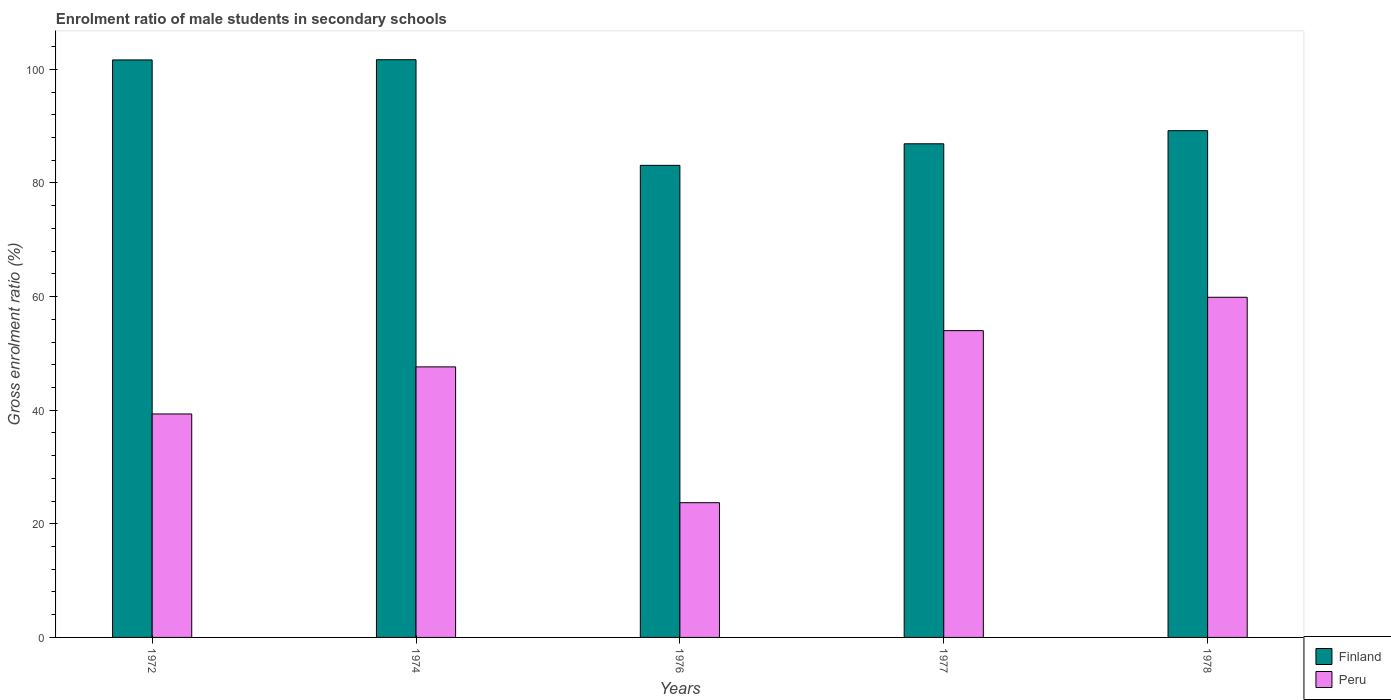How many different coloured bars are there?
Your answer should be compact. 2. Are the number of bars per tick equal to the number of legend labels?
Your answer should be compact. Yes. In how many cases, is the number of bars for a given year not equal to the number of legend labels?
Give a very brief answer. 0. What is the enrolment ratio of male students in secondary schools in Peru in 1977?
Your response must be concise. 54. Across all years, what is the maximum enrolment ratio of male students in secondary schools in Peru?
Keep it short and to the point. 59.88. Across all years, what is the minimum enrolment ratio of male students in secondary schools in Finland?
Provide a succinct answer. 83.1. In which year was the enrolment ratio of male students in secondary schools in Finland maximum?
Keep it short and to the point. 1974. In which year was the enrolment ratio of male students in secondary schools in Peru minimum?
Provide a succinct answer. 1976. What is the total enrolment ratio of male students in secondary schools in Finland in the graph?
Ensure brevity in your answer.  462.54. What is the difference between the enrolment ratio of male students in secondary schools in Finland in 1972 and that in 1976?
Ensure brevity in your answer.  18.56. What is the difference between the enrolment ratio of male students in secondary schools in Peru in 1977 and the enrolment ratio of male students in secondary schools in Finland in 1974?
Your answer should be compact. -47.69. What is the average enrolment ratio of male students in secondary schools in Finland per year?
Offer a terse response. 92.51. In the year 1974, what is the difference between the enrolment ratio of male students in secondary schools in Peru and enrolment ratio of male students in secondary schools in Finland?
Your answer should be very brief. -54.07. In how many years, is the enrolment ratio of male students in secondary schools in Peru greater than 44 %?
Make the answer very short. 3. What is the ratio of the enrolment ratio of male students in secondary schools in Peru in 1977 to that in 1978?
Give a very brief answer. 0.9. Is the enrolment ratio of male students in secondary schools in Finland in 1972 less than that in 1977?
Provide a succinct answer. No. Is the difference between the enrolment ratio of male students in secondary schools in Peru in 1976 and 1977 greater than the difference between the enrolment ratio of male students in secondary schools in Finland in 1976 and 1977?
Offer a terse response. No. What is the difference between the highest and the second highest enrolment ratio of male students in secondary schools in Finland?
Offer a very short reply. 0.04. What is the difference between the highest and the lowest enrolment ratio of male students in secondary schools in Peru?
Offer a terse response. 36.16. In how many years, is the enrolment ratio of male students in secondary schools in Finland greater than the average enrolment ratio of male students in secondary schools in Finland taken over all years?
Your answer should be compact. 2. What does the 2nd bar from the right in 1972 represents?
Give a very brief answer. Finland. What is the difference between two consecutive major ticks on the Y-axis?
Your response must be concise. 20. Does the graph contain grids?
Your answer should be very brief. No. What is the title of the graph?
Your answer should be compact. Enrolment ratio of male students in secondary schools. What is the label or title of the Y-axis?
Provide a succinct answer. Gross enrolment ratio (%). What is the Gross enrolment ratio (%) in Finland in 1972?
Ensure brevity in your answer.  101.66. What is the Gross enrolment ratio (%) of Peru in 1972?
Your answer should be compact. 39.34. What is the Gross enrolment ratio (%) in Finland in 1974?
Your response must be concise. 101.69. What is the Gross enrolment ratio (%) in Peru in 1974?
Make the answer very short. 47.62. What is the Gross enrolment ratio (%) of Finland in 1976?
Offer a very short reply. 83.1. What is the Gross enrolment ratio (%) of Peru in 1976?
Offer a very short reply. 23.71. What is the Gross enrolment ratio (%) of Finland in 1977?
Keep it short and to the point. 86.89. What is the Gross enrolment ratio (%) of Peru in 1977?
Give a very brief answer. 54. What is the Gross enrolment ratio (%) of Finland in 1978?
Your answer should be very brief. 89.2. What is the Gross enrolment ratio (%) of Peru in 1978?
Offer a terse response. 59.88. Across all years, what is the maximum Gross enrolment ratio (%) in Finland?
Ensure brevity in your answer.  101.69. Across all years, what is the maximum Gross enrolment ratio (%) in Peru?
Your response must be concise. 59.88. Across all years, what is the minimum Gross enrolment ratio (%) in Finland?
Your answer should be very brief. 83.1. Across all years, what is the minimum Gross enrolment ratio (%) in Peru?
Offer a very short reply. 23.71. What is the total Gross enrolment ratio (%) of Finland in the graph?
Provide a succinct answer. 462.54. What is the total Gross enrolment ratio (%) of Peru in the graph?
Ensure brevity in your answer.  224.55. What is the difference between the Gross enrolment ratio (%) in Finland in 1972 and that in 1974?
Your response must be concise. -0.04. What is the difference between the Gross enrolment ratio (%) in Peru in 1972 and that in 1974?
Make the answer very short. -8.28. What is the difference between the Gross enrolment ratio (%) of Finland in 1972 and that in 1976?
Offer a terse response. 18.56. What is the difference between the Gross enrolment ratio (%) in Peru in 1972 and that in 1976?
Your response must be concise. 15.62. What is the difference between the Gross enrolment ratio (%) in Finland in 1972 and that in 1977?
Your response must be concise. 14.76. What is the difference between the Gross enrolment ratio (%) of Peru in 1972 and that in 1977?
Your answer should be compact. -14.67. What is the difference between the Gross enrolment ratio (%) in Finland in 1972 and that in 1978?
Offer a very short reply. 12.45. What is the difference between the Gross enrolment ratio (%) in Peru in 1972 and that in 1978?
Provide a short and direct response. -20.54. What is the difference between the Gross enrolment ratio (%) in Finland in 1974 and that in 1976?
Offer a very short reply. 18.59. What is the difference between the Gross enrolment ratio (%) in Peru in 1974 and that in 1976?
Give a very brief answer. 23.91. What is the difference between the Gross enrolment ratio (%) in Finland in 1974 and that in 1977?
Your response must be concise. 14.8. What is the difference between the Gross enrolment ratio (%) in Peru in 1974 and that in 1977?
Keep it short and to the point. -6.38. What is the difference between the Gross enrolment ratio (%) of Finland in 1974 and that in 1978?
Offer a very short reply. 12.49. What is the difference between the Gross enrolment ratio (%) of Peru in 1974 and that in 1978?
Your answer should be compact. -12.26. What is the difference between the Gross enrolment ratio (%) of Finland in 1976 and that in 1977?
Offer a very short reply. -3.79. What is the difference between the Gross enrolment ratio (%) in Peru in 1976 and that in 1977?
Provide a short and direct response. -30.29. What is the difference between the Gross enrolment ratio (%) in Finland in 1976 and that in 1978?
Your answer should be compact. -6.1. What is the difference between the Gross enrolment ratio (%) in Peru in 1976 and that in 1978?
Make the answer very short. -36.16. What is the difference between the Gross enrolment ratio (%) of Finland in 1977 and that in 1978?
Your answer should be very brief. -2.31. What is the difference between the Gross enrolment ratio (%) of Peru in 1977 and that in 1978?
Your answer should be compact. -5.87. What is the difference between the Gross enrolment ratio (%) of Finland in 1972 and the Gross enrolment ratio (%) of Peru in 1974?
Your response must be concise. 54.03. What is the difference between the Gross enrolment ratio (%) of Finland in 1972 and the Gross enrolment ratio (%) of Peru in 1976?
Ensure brevity in your answer.  77.94. What is the difference between the Gross enrolment ratio (%) of Finland in 1972 and the Gross enrolment ratio (%) of Peru in 1977?
Keep it short and to the point. 47.65. What is the difference between the Gross enrolment ratio (%) of Finland in 1972 and the Gross enrolment ratio (%) of Peru in 1978?
Offer a terse response. 41.78. What is the difference between the Gross enrolment ratio (%) of Finland in 1974 and the Gross enrolment ratio (%) of Peru in 1976?
Your response must be concise. 77.98. What is the difference between the Gross enrolment ratio (%) of Finland in 1974 and the Gross enrolment ratio (%) of Peru in 1977?
Your response must be concise. 47.69. What is the difference between the Gross enrolment ratio (%) in Finland in 1974 and the Gross enrolment ratio (%) in Peru in 1978?
Provide a succinct answer. 41.82. What is the difference between the Gross enrolment ratio (%) of Finland in 1976 and the Gross enrolment ratio (%) of Peru in 1977?
Your response must be concise. 29.1. What is the difference between the Gross enrolment ratio (%) of Finland in 1976 and the Gross enrolment ratio (%) of Peru in 1978?
Ensure brevity in your answer.  23.22. What is the difference between the Gross enrolment ratio (%) in Finland in 1977 and the Gross enrolment ratio (%) in Peru in 1978?
Give a very brief answer. 27.02. What is the average Gross enrolment ratio (%) of Finland per year?
Provide a succinct answer. 92.51. What is the average Gross enrolment ratio (%) of Peru per year?
Give a very brief answer. 44.91. In the year 1972, what is the difference between the Gross enrolment ratio (%) of Finland and Gross enrolment ratio (%) of Peru?
Your response must be concise. 62.32. In the year 1974, what is the difference between the Gross enrolment ratio (%) in Finland and Gross enrolment ratio (%) in Peru?
Make the answer very short. 54.07. In the year 1976, what is the difference between the Gross enrolment ratio (%) of Finland and Gross enrolment ratio (%) of Peru?
Your answer should be very brief. 59.38. In the year 1977, what is the difference between the Gross enrolment ratio (%) in Finland and Gross enrolment ratio (%) in Peru?
Provide a succinct answer. 32.89. In the year 1978, what is the difference between the Gross enrolment ratio (%) of Finland and Gross enrolment ratio (%) of Peru?
Provide a succinct answer. 29.32. What is the ratio of the Gross enrolment ratio (%) in Finland in 1972 to that in 1974?
Your answer should be compact. 1. What is the ratio of the Gross enrolment ratio (%) in Peru in 1972 to that in 1974?
Make the answer very short. 0.83. What is the ratio of the Gross enrolment ratio (%) of Finland in 1972 to that in 1976?
Ensure brevity in your answer.  1.22. What is the ratio of the Gross enrolment ratio (%) in Peru in 1972 to that in 1976?
Ensure brevity in your answer.  1.66. What is the ratio of the Gross enrolment ratio (%) of Finland in 1972 to that in 1977?
Keep it short and to the point. 1.17. What is the ratio of the Gross enrolment ratio (%) in Peru in 1972 to that in 1977?
Offer a very short reply. 0.73. What is the ratio of the Gross enrolment ratio (%) of Finland in 1972 to that in 1978?
Provide a short and direct response. 1.14. What is the ratio of the Gross enrolment ratio (%) of Peru in 1972 to that in 1978?
Give a very brief answer. 0.66. What is the ratio of the Gross enrolment ratio (%) in Finland in 1974 to that in 1976?
Your response must be concise. 1.22. What is the ratio of the Gross enrolment ratio (%) of Peru in 1974 to that in 1976?
Offer a terse response. 2.01. What is the ratio of the Gross enrolment ratio (%) in Finland in 1974 to that in 1977?
Your answer should be very brief. 1.17. What is the ratio of the Gross enrolment ratio (%) in Peru in 1974 to that in 1977?
Keep it short and to the point. 0.88. What is the ratio of the Gross enrolment ratio (%) of Finland in 1974 to that in 1978?
Make the answer very short. 1.14. What is the ratio of the Gross enrolment ratio (%) of Peru in 1974 to that in 1978?
Your answer should be compact. 0.8. What is the ratio of the Gross enrolment ratio (%) of Finland in 1976 to that in 1977?
Offer a very short reply. 0.96. What is the ratio of the Gross enrolment ratio (%) of Peru in 1976 to that in 1977?
Provide a succinct answer. 0.44. What is the ratio of the Gross enrolment ratio (%) in Finland in 1976 to that in 1978?
Your answer should be compact. 0.93. What is the ratio of the Gross enrolment ratio (%) of Peru in 1976 to that in 1978?
Give a very brief answer. 0.4. What is the ratio of the Gross enrolment ratio (%) in Finland in 1977 to that in 1978?
Your answer should be compact. 0.97. What is the ratio of the Gross enrolment ratio (%) of Peru in 1977 to that in 1978?
Provide a short and direct response. 0.9. What is the difference between the highest and the second highest Gross enrolment ratio (%) in Finland?
Offer a very short reply. 0.04. What is the difference between the highest and the second highest Gross enrolment ratio (%) in Peru?
Offer a terse response. 5.87. What is the difference between the highest and the lowest Gross enrolment ratio (%) in Finland?
Offer a terse response. 18.59. What is the difference between the highest and the lowest Gross enrolment ratio (%) of Peru?
Ensure brevity in your answer.  36.16. 